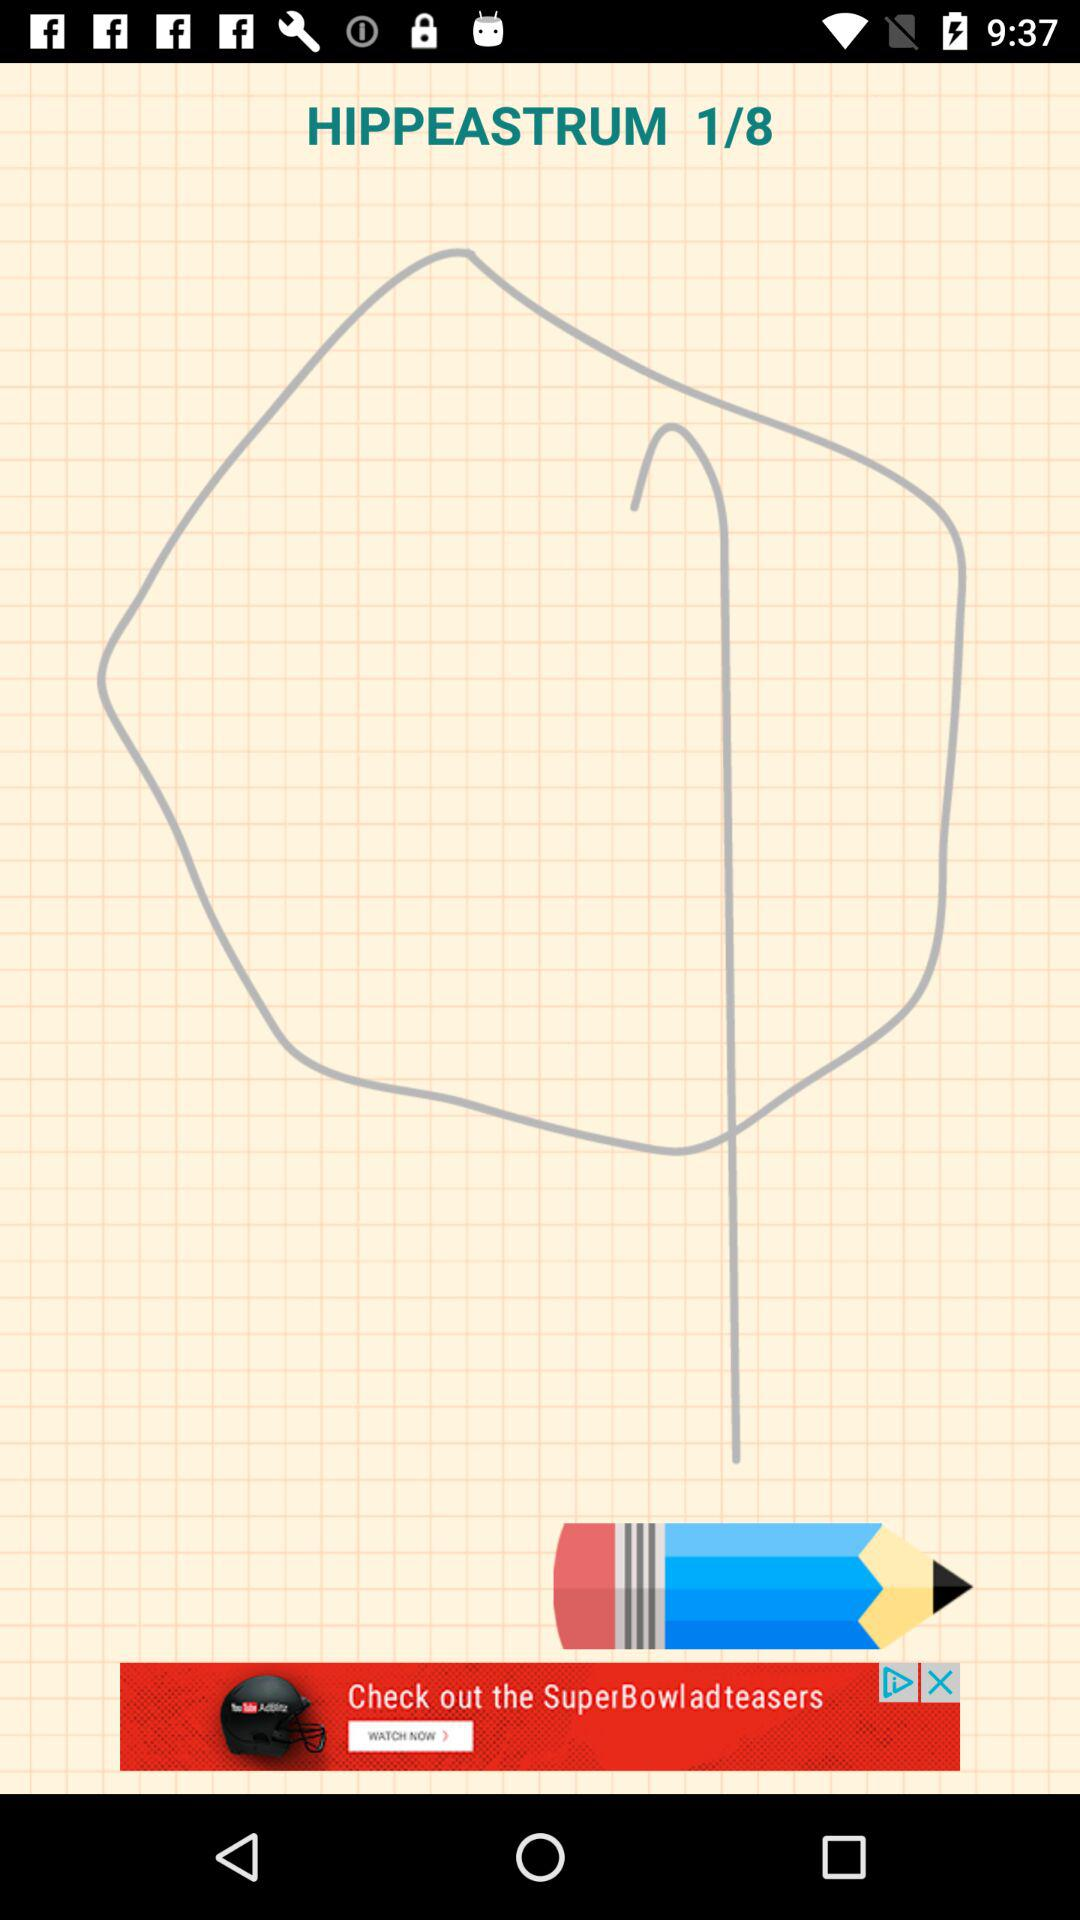At what image am I on? You are on first image. 